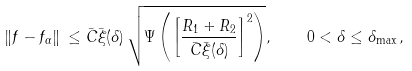<formula> <loc_0><loc_0><loc_500><loc_500>\| f - f _ { \alpha } \| \, \leq \bar { C } \bar { \xi } ( \delta ) \, \sqrt { \Psi \left ( \left [ \frac { R _ { 1 } + R _ { 2 } } { \bar { C } \bar { \xi } ( \delta ) } \right ] ^ { 2 } \right ) } , \quad 0 < \delta \leq \delta _ { \max } \, ,</formula> 